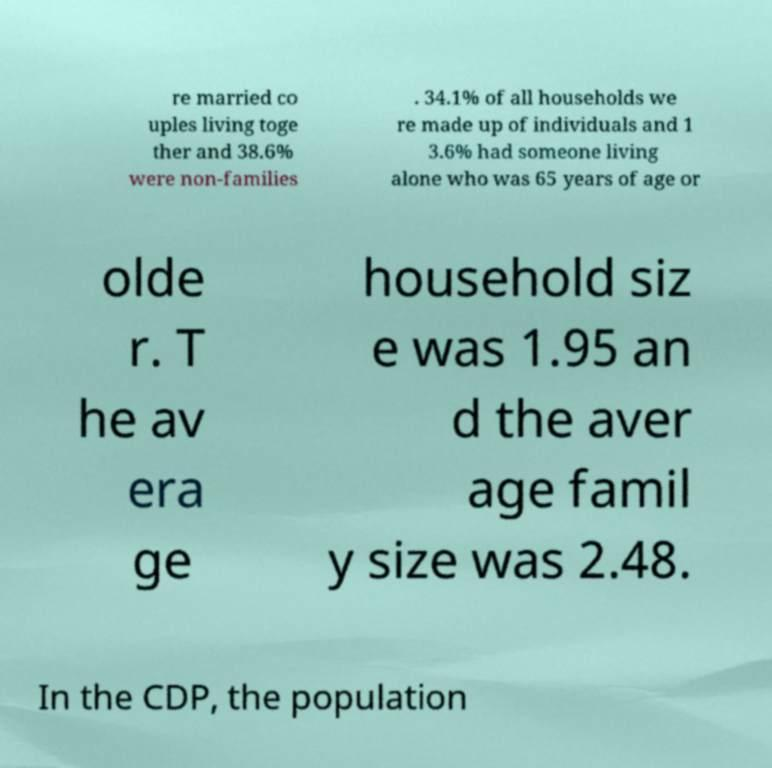Please identify and transcribe the text found in this image. re married co uples living toge ther and 38.6% were non-families . 34.1% of all households we re made up of individuals and 1 3.6% had someone living alone who was 65 years of age or olde r. T he av era ge household siz e was 1.95 an d the aver age famil y size was 2.48. In the CDP, the population 